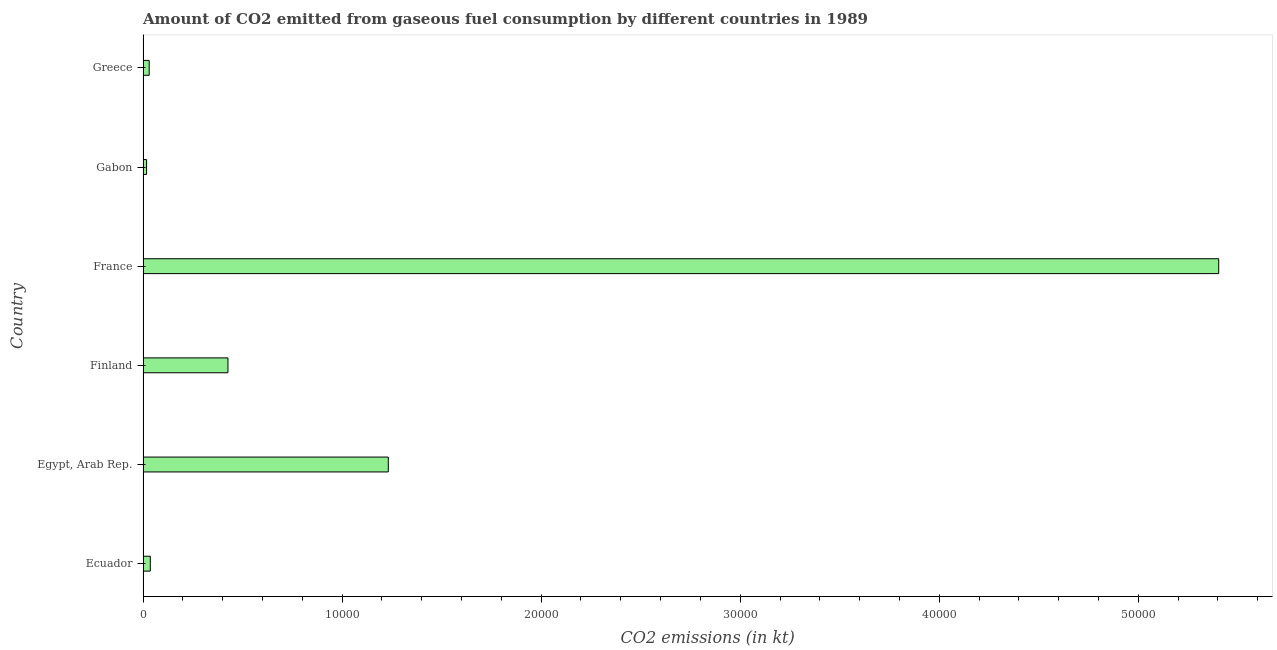Does the graph contain any zero values?
Give a very brief answer. No. What is the title of the graph?
Provide a short and direct response. Amount of CO2 emitted from gaseous fuel consumption by different countries in 1989. What is the label or title of the X-axis?
Ensure brevity in your answer.  CO2 emissions (in kt). What is the co2 emissions from gaseous fuel consumption in Egypt, Arab Rep.?
Your response must be concise. 1.23e+04. Across all countries, what is the maximum co2 emissions from gaseous fuel consumption?
Your answer should be very brief. 5.40e+04. Across all countries, what is the minimum co2 emissions from gaseous fuel consumption?
Keep it short and to the point. 176.02. In which country was the co2 emissions from gaseous fuel consumption maximum?
Ensure brevity in your answer.  France. In which country was the co2 emissions from gaseous fuel consumption minimum?
Give a very brief answer. Gabon. What is the sum of the co2 emissions from gaseous fuel consumption?
Keep it short and to the point. 7.15e+04. What is the difference between the co2 emissions from gaseous fuel consumption in Ecuador and France?
Your response must be concise. -5.37e+04. What is the average co2 emissions from gaseous fuel consumption per country?
Make the answer very short. 1.19e+04. What is the median co2 emissions from gaseous fuel consumption?
Make the answer very short. 2313.88. What is the ratio of the co2 emissions from gaseous fuel consumption in Egypt, Arab Rep. to that in Finland?
Give a very brief answer. 2.89. Is the co2 emissions from gaseous fuel consumption in Egypt, Arab Rep. less than that in Greece?
Give a very brief answer. No. Is the difference between the co2 emissions from gaseous fuel consumption in Finland and Gabon greater than the difference between any two countries?
Your answer should be very brief. No. What is the difference between the highest and the second highest co2 emissions from gaseous fuel consumption?
Offer a very short reply. 4.17e+04. Is the sum of the co2 emissions from gaseous fuel consumption in Egypt, Arab Rep. and Finland greater than the maximum co2 emissions from gaseous fuel consumption across all countries?
Your response must be concise. No. What is the difference between the highest and the lowest co2 emissions from gaseous fuel consumption?
Provide a succinct answer. 5.39e+04. In how many countries, is the co2 emissions from gaseous fuel consumption greater than the average co2 emissions from gaseous fuel consumption taken over all countries?
Keep it short and to the point. 2. How many countries are there in the graph?
Your answer should be compact. 6. Are the values on the major ticks of X-axis written in scientific E-notation?
Offer a terse response. No. What is the CO2 emissions (in kt) in Ecuador?
Make the answer very short. 363.03. What is the CO2 emissions (in kt) in Egypt, Arab Rep.?
Provide a succinct answer. 1.23e+04. What is the CO2 emissions (in kt) of Finland?
Provide a succinct answer. 4264.72. What is the CO2 emissions (in kt) in France?
Provide a succinct answer. 5.40e+04. What is the CO2 emissions (in kt) of Gabon?
Offer a very short reply. 176.02. What is the CO2 emissions (in kt) in Greece?
Your answer should be compact. 308.03. What is the difference between the CO2 emissions (in kt) in Ecuador and Egypt, Arab Rep.?
Your answer should be very brief. -1.20e+04. What is the difference between the CO2 emissions (in kt) in Ecuador and Finland?
Your answer should be compact. -3901.69. What is the difference between the CO2 emissions (in kt) in Ecuador and France?
Make the answer very short. -5.37e+04. What is the difference between the CO2 emissions (in kt) in Ecuador and Gabon?
Provide a succinct answer. 187.02. What is the difference between the CO2 emissions (in kt) in Ecuador and Greece?
Make the answer very short. 55.01. What is the difference between the CO2 emissions (in kt) in Egypt, Arab Rep. and Finland?
Give a very brief answer. 8056.4. What is the difference between the CO2 emissions (in kt) in Egypt, Arab Rep. and France?
Keep it short and to the point. -4.17e+04. What is the difference between the CO2 emissions (in kt) in Egypt, Arab Rep. and Gabon?
Give a very brief answer. 1.21e+04. What is the difference between the CO2 emissions (in kt) in Egypt, Arab Rep. and Greece?
Keep it short and to the point. 1.20e+04. What is the difference between the CO2 emissions (in kt) in Finland and France?
Offer a very short reply. -4.98e+04. What is the difference between the CO2 emissions (in kt) in Finland and Gabon?
Keep it short and to the point. 4088.7. What is the difference between the CO2 emissions (in kt) in Finland and Greece?
Offer a terse response. 3956.69. What is the difference between the CO2 emissions (in kt) in France and Gabon?
Your answer should be very brief. 5.39e+04. What is the difference between the CO2 emissions (in kt) in France and Greece?
Give a very brief answer. 5.37e+04. What is the difference between the CO2 emissions (in kt) in Gabon and Greece?
Provide a short and direct response. -132.01. What is the ratio of the CO2 emissions (in kt) in Ecuador to that in Egypt, Arab Rep.?
Provide a short and direct response. 0.03. What is the ratio of the CO2 emissions (in kt) in Ecuador to that in Finland?
Your answer should be compact. 0.09. What is the ratio of the CO2 emissions (in kt) in Ecuador to that in France?
Give a very brief answer. 0.01. What is the ratio of the CO2 emissions (in kt) in Ecuador to that in Gabon?
Your response must be concise. 2.06. What is the ratio of the CO2 emissions (in kt) in Ecuador to that in Greece?
Keep it short and to the point. 1.18. What is the ratio of the CO2 emissions (in kt) in Egypt, Arab Rep. to that in Finland?
Provide a short and direct response. 2.89. What is the ratio of the CO2 emissions (in kt) in Egypt, Arab Rep. to that in France?
Ensure brevity in your answer.  0.23. What is the ratio of the CO2 emissions (in kt) in Egypt, Arab Rep. to that in Greece?
Ensure brevity in your answer.  40. What is the ratio of the CO2 emissions (in kt) in Finland to that in France?
Make the answer very short. 0.08. What is the ratio of the CO2 emissions (in kt) in Finland to that in Gabon?
Ensure brevity in your answer.  24.23. What is the ratio of the CO2 emissions (in kt) in Finland to that in Greece?
Provide a succinct answer. 13.85. What is the ratio of the CO2 emissions (in kt) in France to that in Gabon?
Offer a terse response. 307.02. What is the ratio of the CO2 emissions (in kt) in France to that in Greece?
Provide a succinct answer. 175.44. What is the ratio of the CO2 emissions (in kt) in Gabon to that in Greece?
Offer a very short reply. 0.57. 